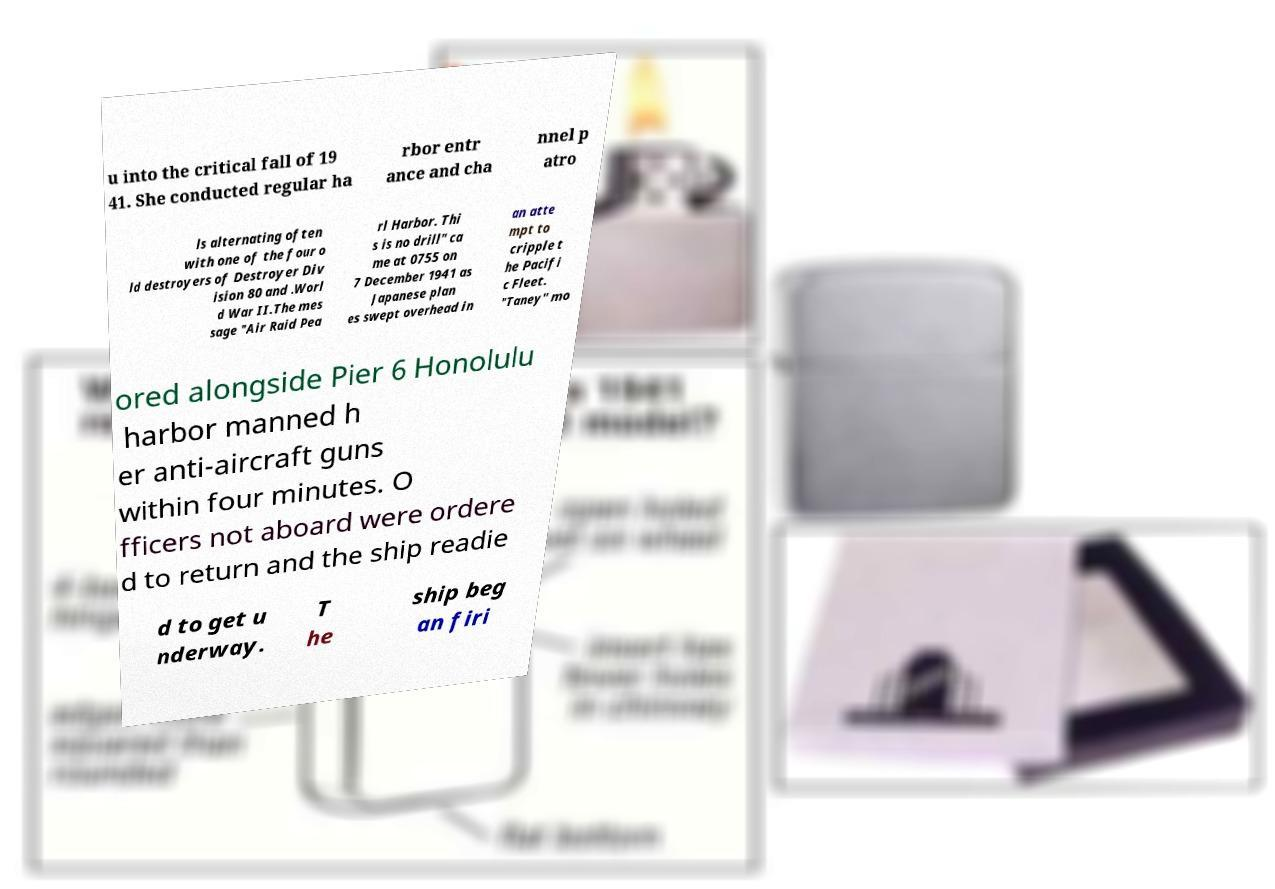Please read and relay the text visible in this image. What does it say? u into the critical fall of 19 41. She conducted regular ha rbor entr ance and cha nnel p atro ls alternating often with one of the four o ld destroyers of Destroyer Div ision 80 and .Worl d War II.The mes sage "Air Raid Pea rl Harbor. Thi s is no drill" ca me at 0755 on 7 December 1941 as Japanese plan es swept overhead in an atte mpt to cripple t he Pacifi c Fleet. "Taney" mo ored alongside Pier 6 Honolulu harbor manned h er anti-aircraft guns within four minutes. O fficers not aboard were ordere d to return and the ship readie d to get u nderway. T he ship beg an firi 